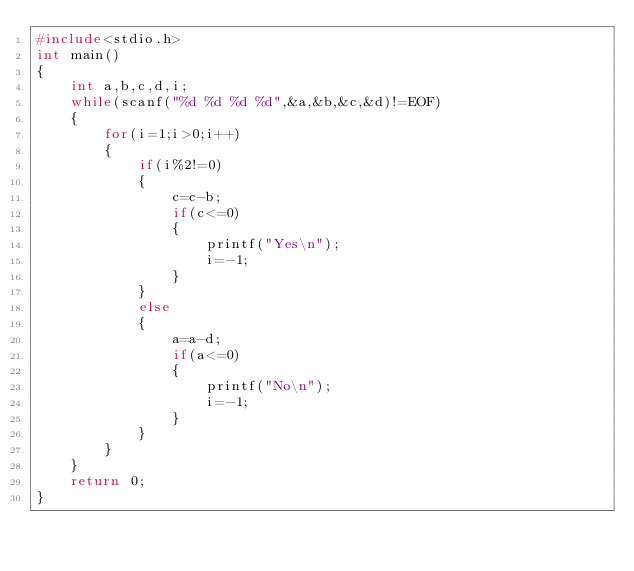Convert code to text. <code><loc_0><loc_0><loc_500><loc_500><_C_>#include<stdio.h>
int main()
{
    int a,b,c,d,i;
    while(scanf("%d %d %d %d",&a,&b,&c,&d)!=EOF)
    {
        for(i=1;i>0;i++)
        {
            if(i%2!=0)
            {
                c=c-b;
                if(c<=0)
                {
                    printf("Yes\n");
                    i=-1;
                }
            }
            else
            {
                a=a-d;
                if(a<=0)
                {
                    printf("No\n");
                    i=-1;
                }
            }
        }
    }
    return 0;
}
</code> 